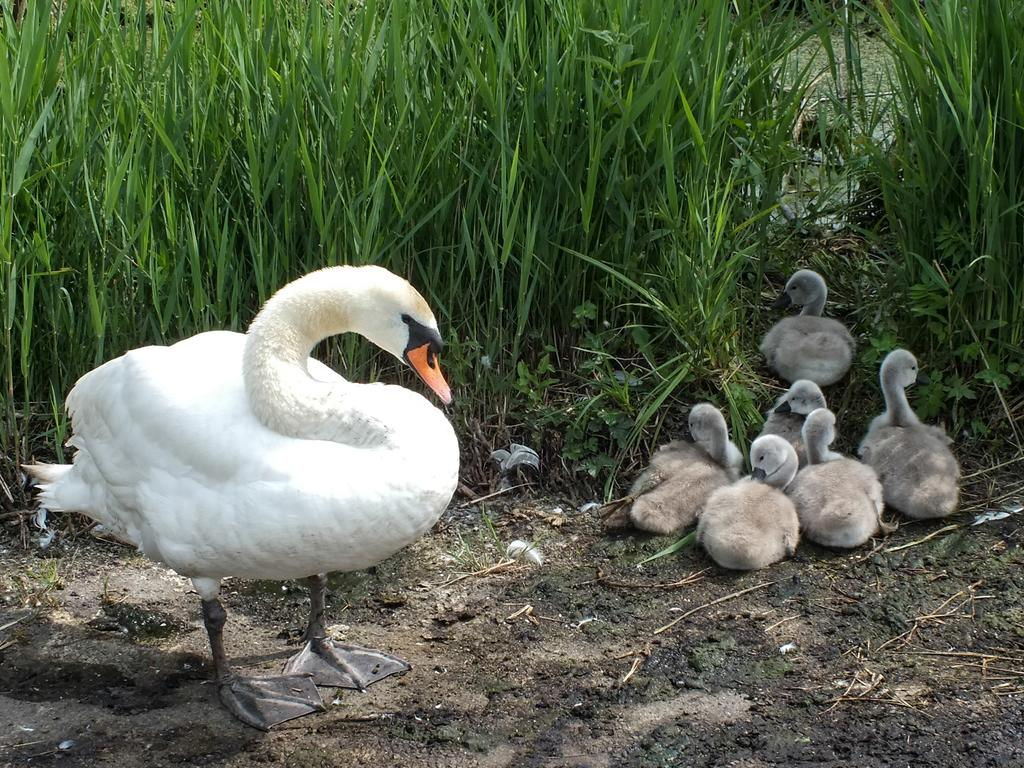What type of animals can be seen in the image? There are white color ducks in the image. What is the background of the image? There is grass visible in the image. What flavor of gun is being traded in the image? There is no gun or trade present in the image; it features white color ducks and grass. 